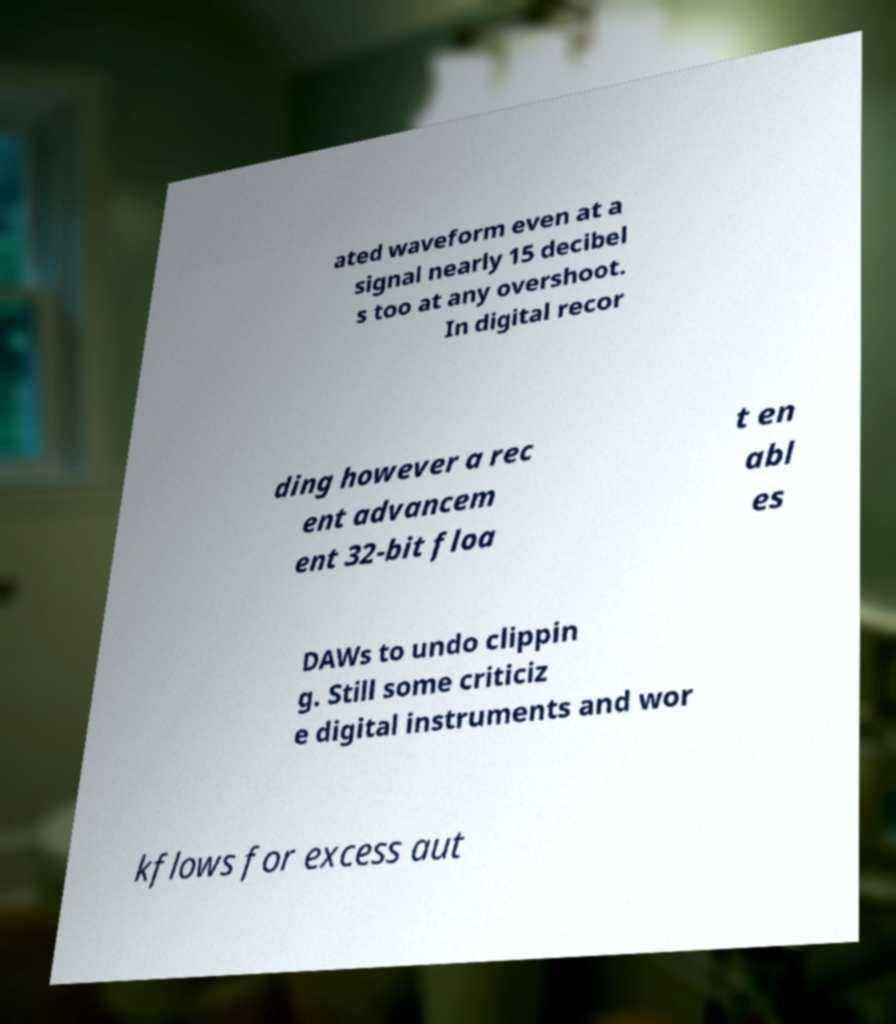I need the written content from this picture converted into text. Can you do that? ated waveform even at a signal nearly 15 decibel s too at any overshoot. In digital recor ding however a rec ent advancem ent 32-bit floa t en abl es DAWs to undo clippin g. Still some criticiz e digital instruments and wor kflows for excess aut 